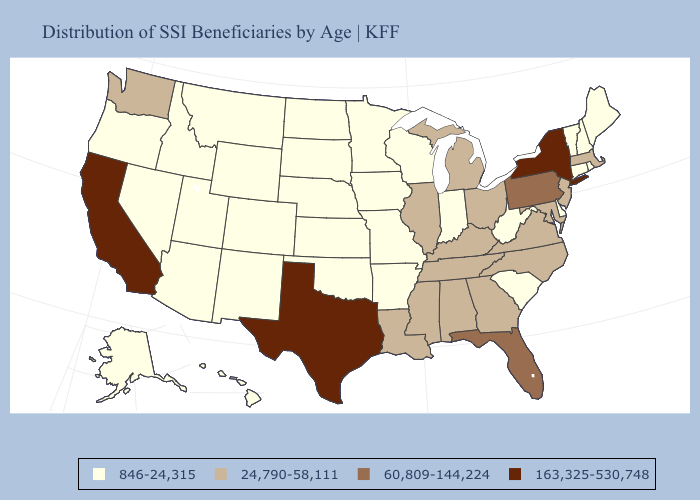Does Texas have the highest value in the USA?
Concise answer only. Yes. How many symbols are there in the legend?
Keep it brief. 4. Name the states that have a value in the range 163,325-530,748?
Quick response, please. California, New York, Texas. Name the states that have a value in the range 60,809-144,224?
Short answer required. Florida, Pennsylvania. Does Illinois have the same value as Ohio?
Be succinct. Yes. What is the value of North Carolina?
Short answer required. 24,790-58,111. Does New Hampshire have a higher value than Wyoming?
Short answer required. No. Among the states that border Indiana , which have the lowest value?
Keep it brief. Illinois, Kentucky, Michigan, Ohio. Name the states that have a value in the range 163,325-530,748?
Concise answer only. California, New York, Texas. What is the lowest value in states that border Vermont?
Answer briefly. 846-24,315. Name the states that have a value in the range 846-24,315?
Concise answer only. Alaska, Arizona, Arkansas, Colorado, Connecticut, Delaware, Hawaii, Idaho, Indiana, Iowa, Kansas, Maine, Minnesota, Missouri, Montana, Nebraska, Nevada, New Hampshire, New Mexico, North Dakota, Oklahoma, Oregon, Rhode Island, South Carolina, South Dakota, Utah, Vermont, West Virginia, Wisconsin, Wyoming. How many symbols are there in the legend?
Give a very brief answer. 4. Name the states that have a value in the range 163,325-530,748?
Be succinct. California, New York, Texas. What is the lowest value in the USA?
Write a very short answer. 846-24,315. What is the value of Oklahoma?
Write a very short answer. 846-24,315. 